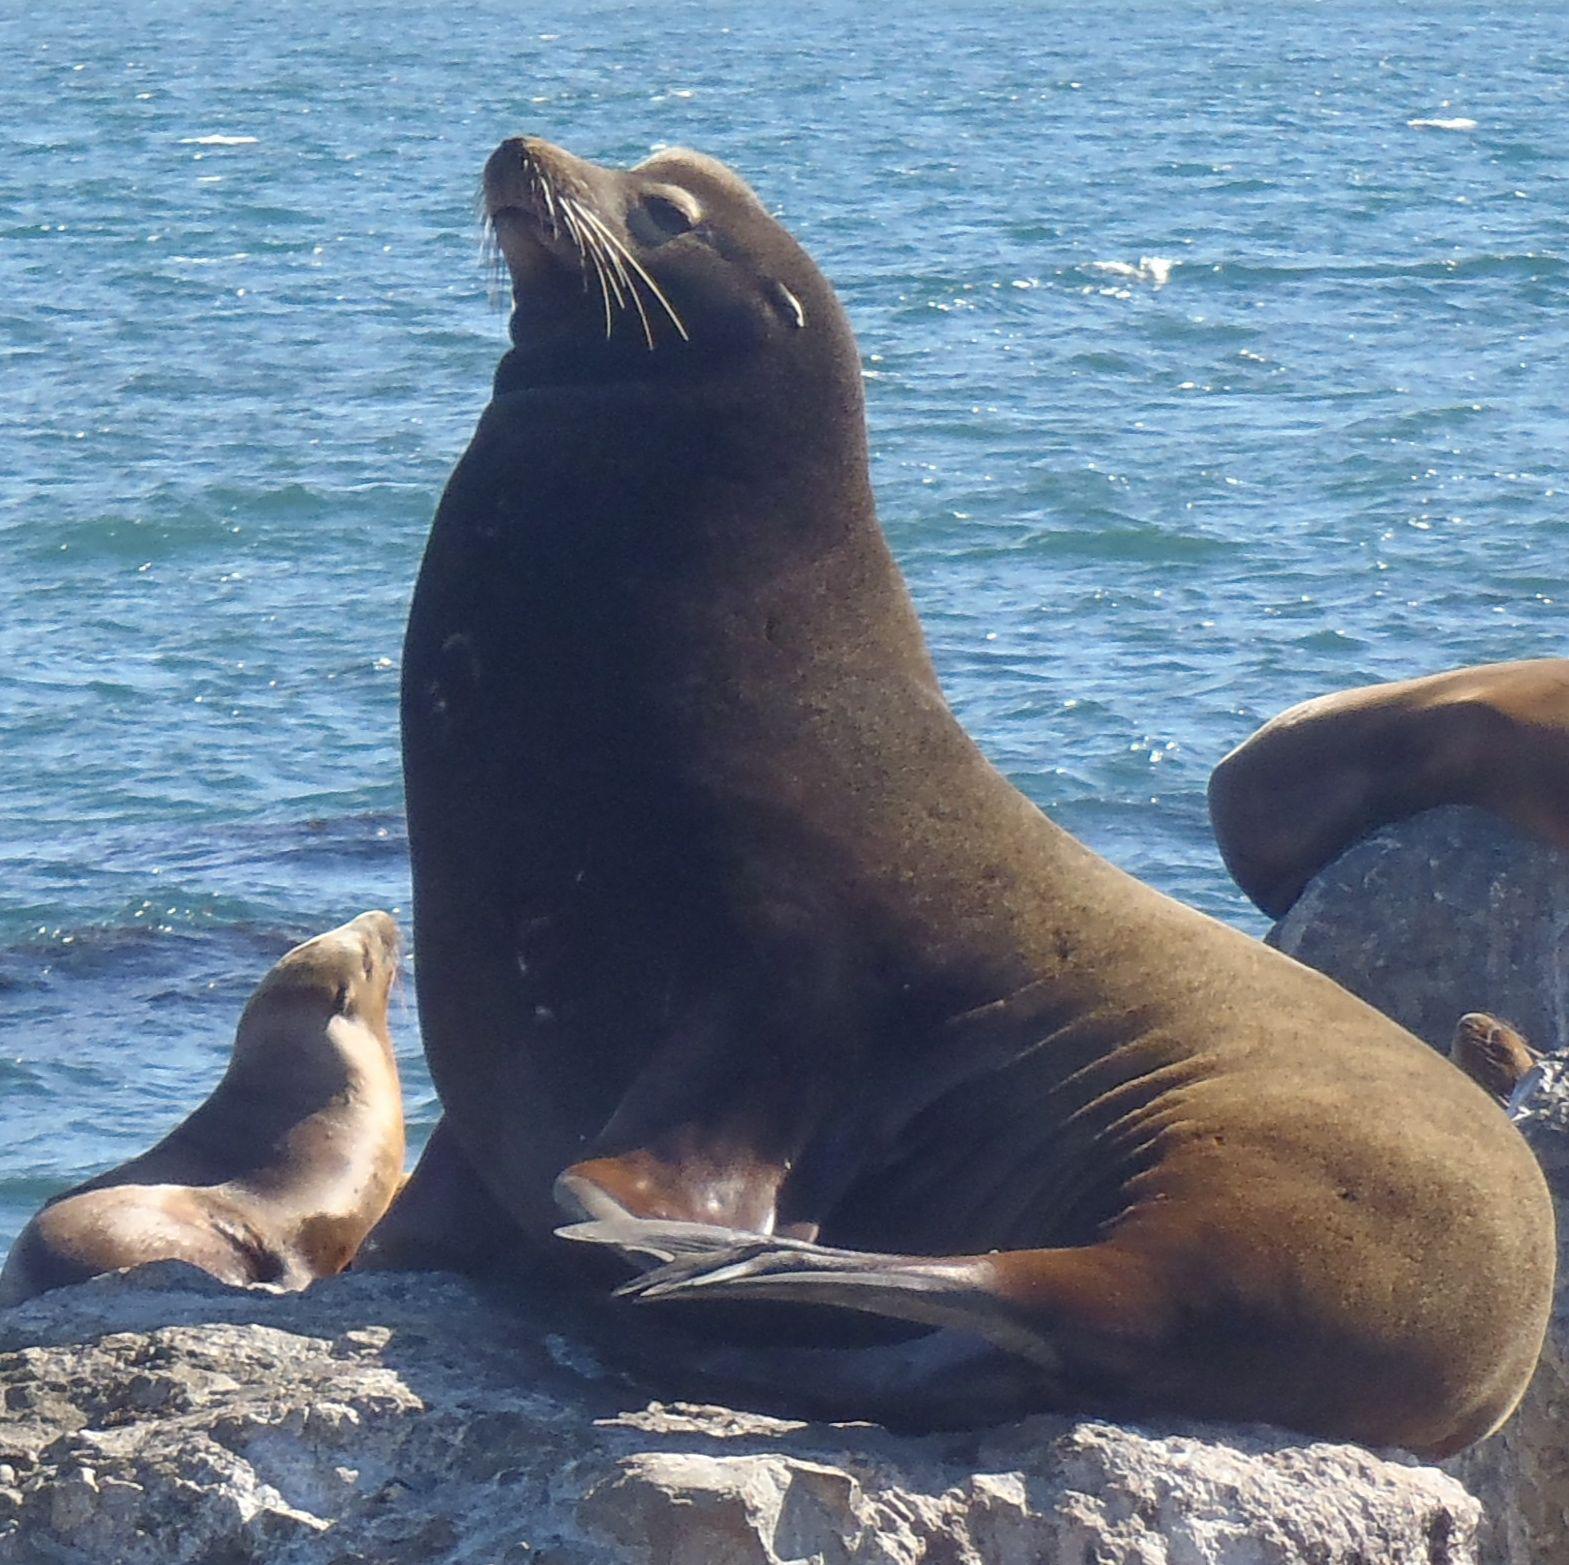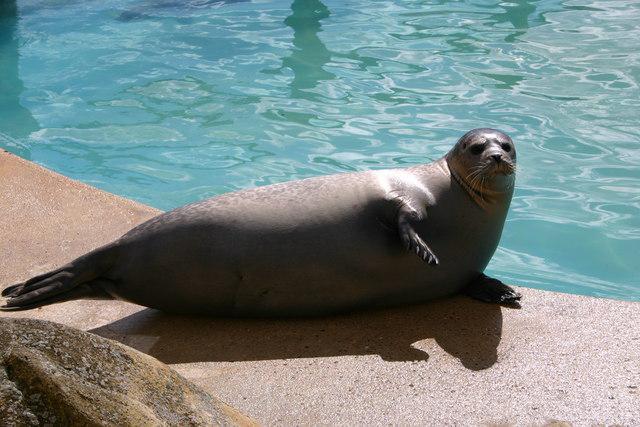The first image is the image on the left, the second image is the image on the right. Considering the images on both sides, is "Three animals are near the water." valid? Answer yes or no. Yes. The first image is the image on the left, the second image is the image on the right. For the images shown, is this caption "At least one image shows a seal on the edge of a man-made pool." true? Answer yes or no. Yes. 